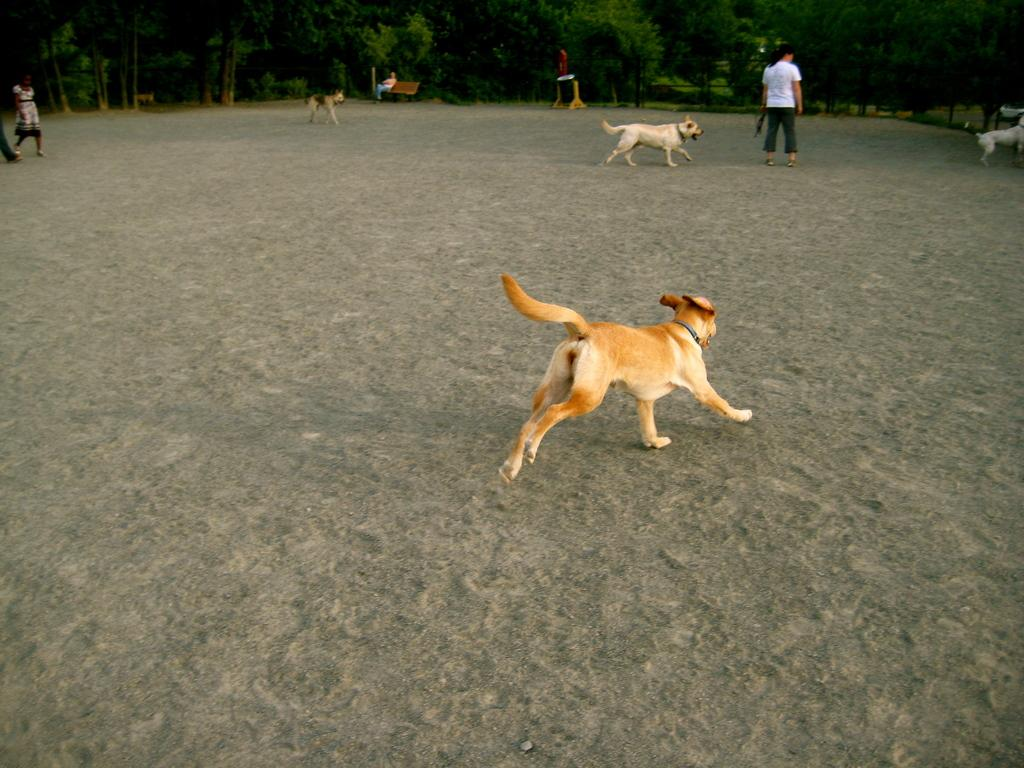What are the dogs in the image doing? The dogs are running in the image. What is the texture of the ground in the image? The ground is sandy. Can you describe the object in the image? Unfortunately, the facts provided do not give enough information to describe the object in the image. What type of seating is present in the image? There is a bench in the image. What type of vegetation is present in the image? There are trees in the image. What are the people in the image wearing? The people in the image are wearing clothes. Who is sitting on the bench in the image? There is a person sitting on the bench in the image. Can you hear the crow whistling in the image? There is no mention of a crow or whistling in the image, so it cannot be heard. 